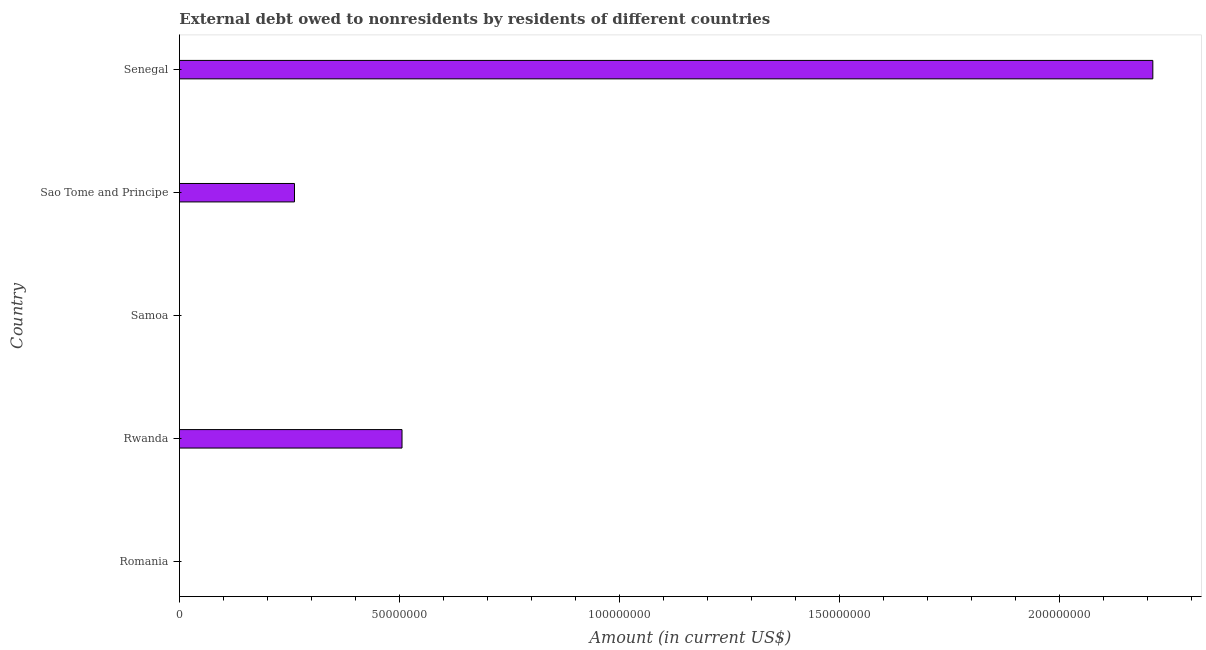Does the graph contain any zero values?
Keep it short and to the point. Yes. Does the graph contain grids?
Make the answer very short. No. What is the title of the graph?
Provide a short and direct response. External debt owed to nonresidents by residents of different countries. What is the debt in Rwanda?
Provide a succinct answer. 5.06e+07. Across all countries, what is the maximum debt?
Offer a very short reply. 2.21e+08. Across all countries, what is the minimum debt?
Your response must be concise. 0. In which country was the debt maximum?
Provide a short and direct response. Senegal. What is the sum of the debt?
Your answer should be compact. 2.98e+08. What is the difference between the debt in Rwanda and Sao Tome and Principe?
Your response must be concise. 2.44e+07. What is the average debt per country?
Provide a succinct answer. 5.96e+07. What is the median debt?
Give a very brief answer. 2.62e+07. What is the ratio of the debt in Sao Tome and Principe to that in Senegal?
Your response must be concise. 0.12. Is the debt in Rwanda less than that in Senegal?
Your answer should be very brief. Yes. What is the difference between the highest and the second highest debt?
Keep it short and to the point. 1.71e+08. Is the sum of the debt in Sao Tome and Principe and Senegal greater than the maximum debt across all countries?
Give a very brief answer. Yes. What is the difference between the highest and the lowest debt?
Offer a terse response. 2.21e+08. In how many countries, is the debt greater than the average debt taken over all countries?
Ensure brevity in your answer.  1. Are all the bars in the graph horizontal?
Keep it short and to the point. Yes. What is the difference between two consecutive major ticks on the X-axis?
Offer a terse response. 5.00e+07. Are the values on the major ticks of X-axis written in scientific E-notation?
Provide a short and direct response. No. What is the Amount (in current US$) in Rwanda?
Provide a short and direct response. 5.06e+07. What is the Amount (in current US$) in Sao Tome and Principe?
Your answer should be very brief. 2.62e+07. What is the Amount (in current US$) in Senegal?
Your answer should be compact. 2.21e+08. What is the difference between the Amount (in current US$) in Rwanda and Sao Tome and Principe?
Provide a short and direct response. 2.44e+07. What is the difference between the Amount (in current US$) in Rwanda and Senegal?
Make the answer very short. -1.71e+08. What is the difference between the Amount (in current US$) in Sao Tome and Principe and Senegal?
Provide a succinct answer. -1.95e+08. What is the ratio of the Amount (in current US$) in Rwanda to that in Sao Tome and Principe?
Your answer should be compact. 1.94. What is the ratio of the Amount (in current US$) in Rwanda to that in Senegal?
Make the answer very short. 0.23. What is the ratio of the Amount (in current US$) in Sao Tome and Principe to that in Senegal?
Keep it short and to the point. 0.12. 